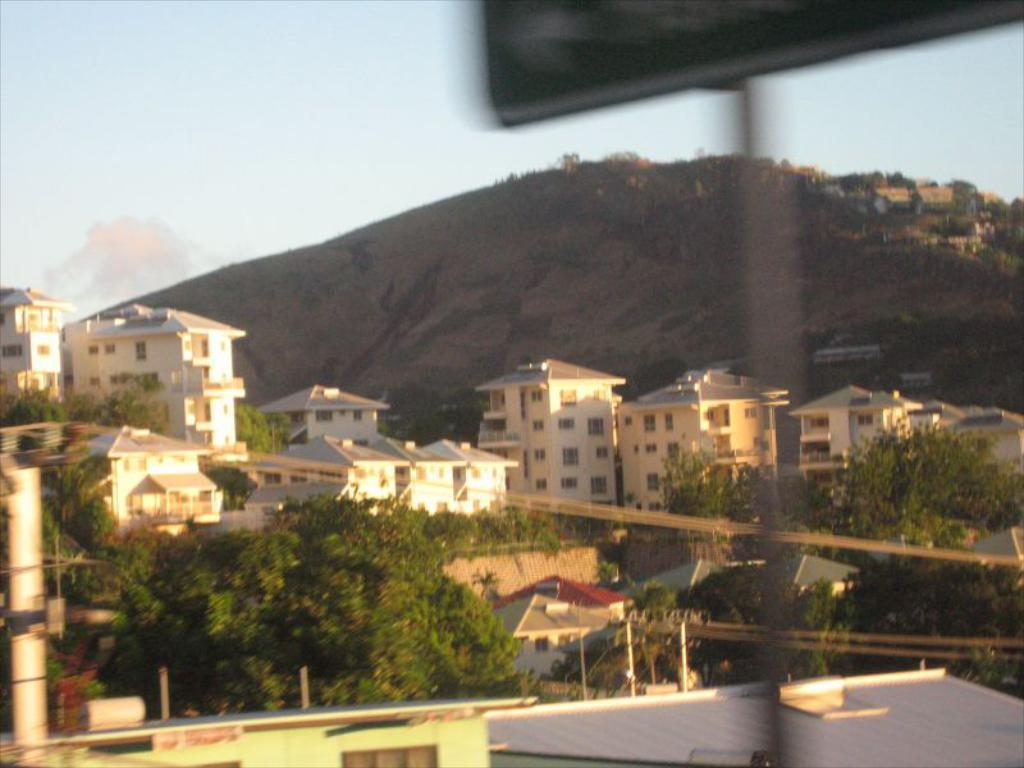What can be seen in the foreground of the image? In the foreground of the image, there are trees, buildings, windows, poles, and wires. What is visible in the background of the image? In the background of the image, there are mountains and the sky. Can you describe the time of day when the image was likely taken? The image was likely taken during the day, as the sky is visible and there is no indication of darkness. What letters can be seen on the trees in the image? There are no letters visible on the trees in the image. What is the mouth of the mountain doing in the image? There is no mouth present on the mountains in the image. 